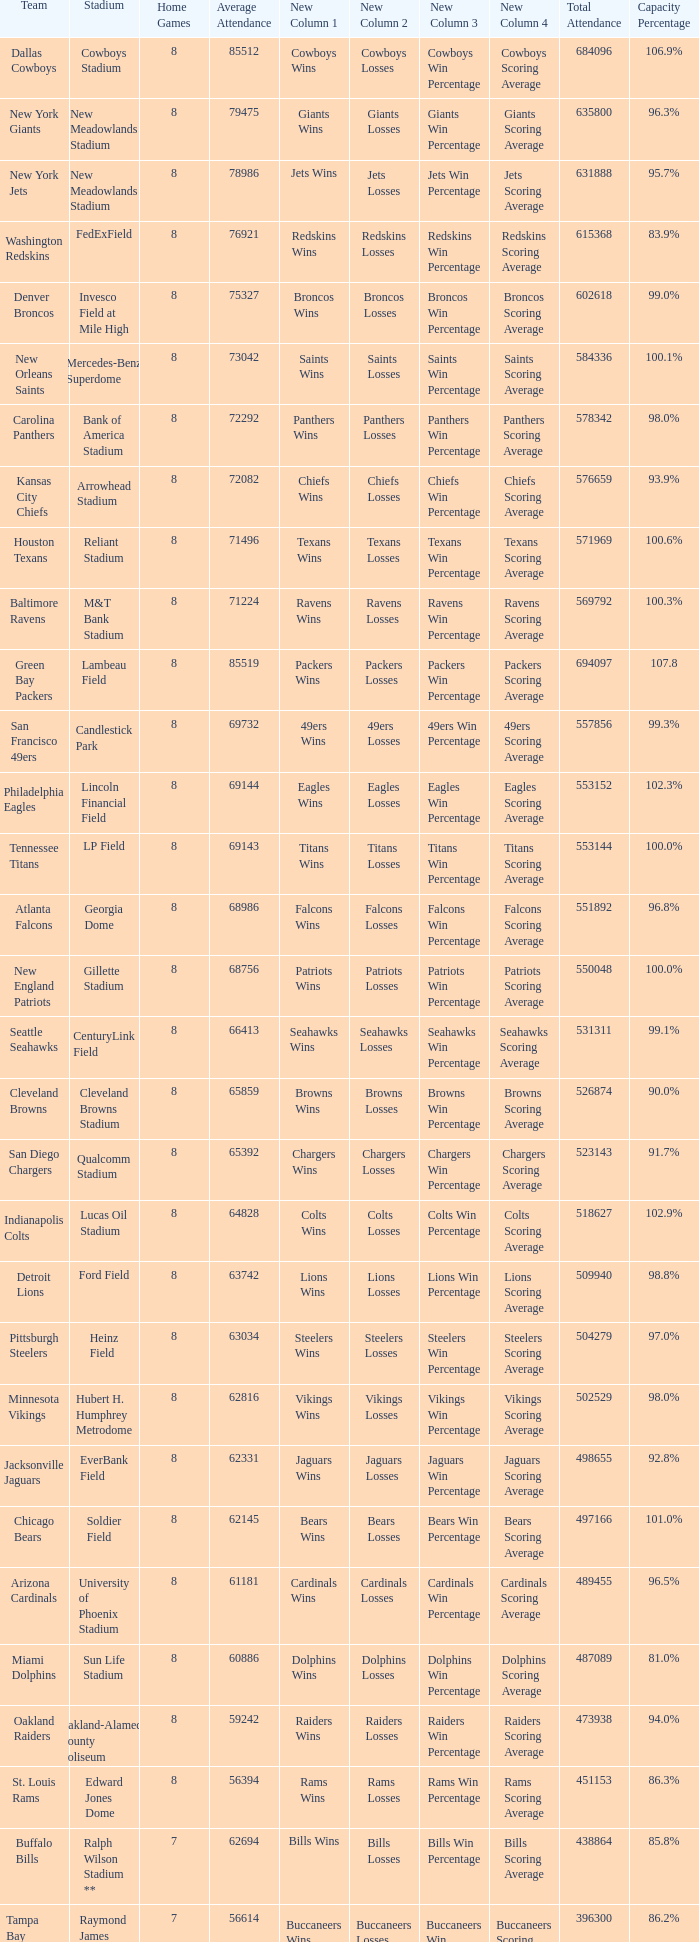What is the capacity percentage when the total attendance is 509940? 98.8%. 